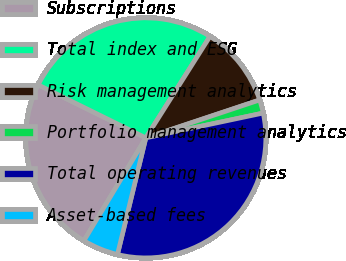<chart> <loc_0><loc_0><loc_500><loc_500><pie_chart><fcel>Subscriptions<fcel>Total index and ESG<fcel>Risk management analytics<fcel>Portfolio management analytics<fcel>Total operating revenues<fcel>Asset-based fees<nl><fcel>23.66%<fcel>26.69%<fcel>10.91%<fcel>1.8%<fcel>32.12%<fcel>4.83%<nl></chart> 